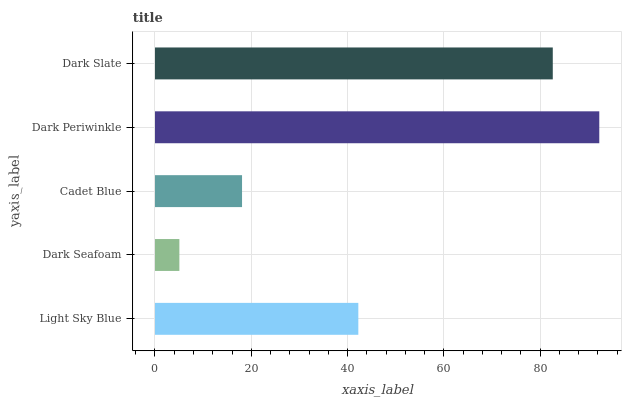Is Dark Seafoam the minimum?
Answer yes or no. Yes. Is Dark Periwinkle the maximum?
Answer yes or no. Yes. Is Cadet Blue the minimum?
Answer yes or no. No. Is Cadet Blue the maximum?
Answer yes or no. No. Is Cadet Blue greater than Dark Seafoam?
Answer yes or no. Yes. Is Dark Seafoam less than Cadet Blue?
Answer yes or no. Yes. Is Dark Seafoam greater than Cadet Blue?
Answer yes or no. No. Is Cadet Blue less than Dark Seafoam?
Answer yes or no. No. Is Light Sky Blue the high median?
Answer yes or no. Yes. Is Light Sky Blue the low median?
Answer yes or no. Yes. Is Cadet Blue the high median?
Answer yes or no. No. Is Dark Slate the low median?
Answer yes or no. No. 